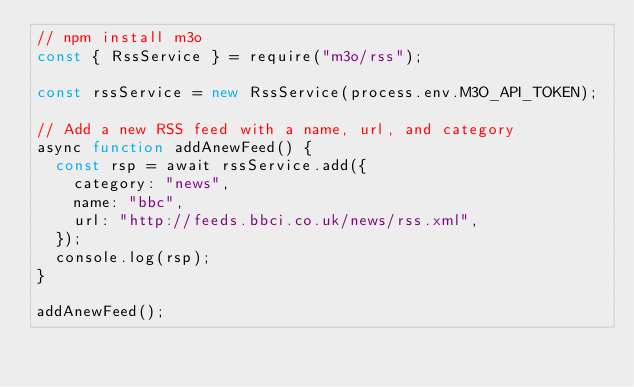Convert code to text. <code><loc_0><loc_0><loc_500><loc_500><_JavaScript_>// npm install m3o
const { RssService } = require("m3o/rss");

const rssService = new RssService(process.env.M3O_API_TOKEN);

// Add a new RSS feed with a name, url, and category
async function addAnewFeed() {
  const rsp = await rssService.add({
    category: "news",
    name: "bbc",
    url: "http://feeds.bbci.co.uk/news/rss.xml",
  });
  console.log(rsp);
}

addAnewFeed();
</code> 